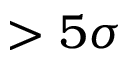<formula> <loc_0><loc_0><loc_500><loc_500>> 5 \sigma</formula> 